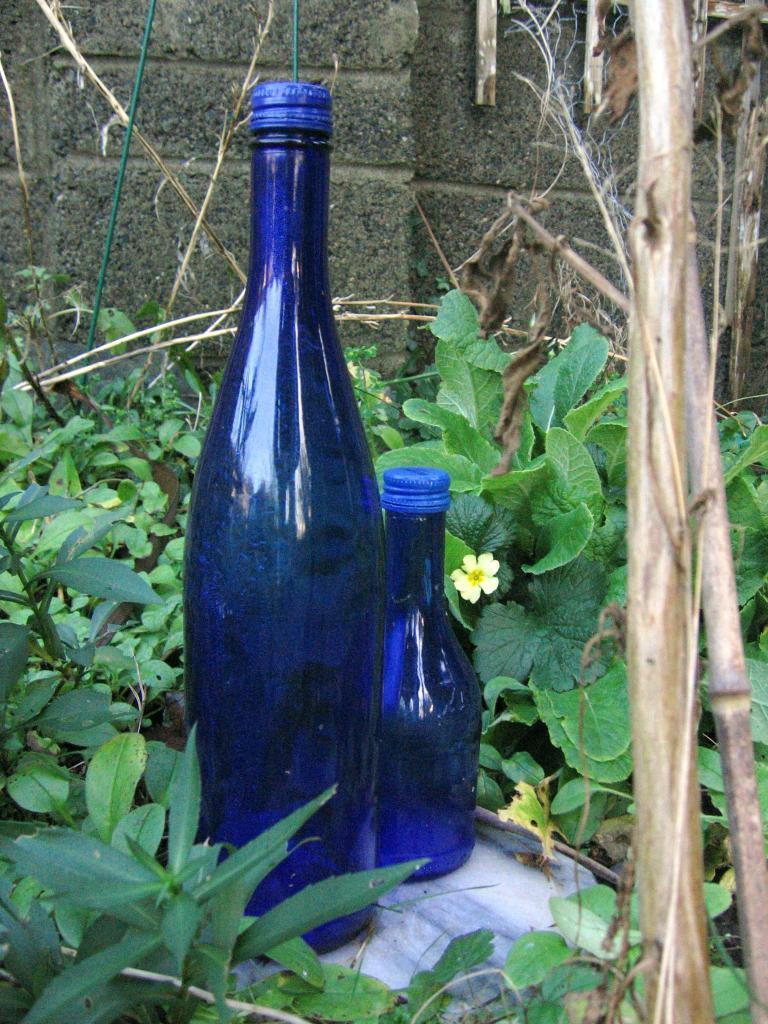What are the main objects in the center of the image? There are two bottles in the center of the image. What is surrounding the bottles? The bottles are surrounded by plants. What can be seen behind the bottles? There is a wall behind the bottles. How does the hill affect the bottles in the image? There is no hill present in the image; it only features two bottles surrounded by plants and a wall in the background. 